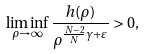<formula> <loc_0><loc_0><loc_500><loc_500>\liminf _ { \rho \rightarrow \infty } \frac { h ( \rho ) } { \rho ^ { \frac { N - 2 } { N } \gamma + \varepsilon } } > 0 ,</formula> 